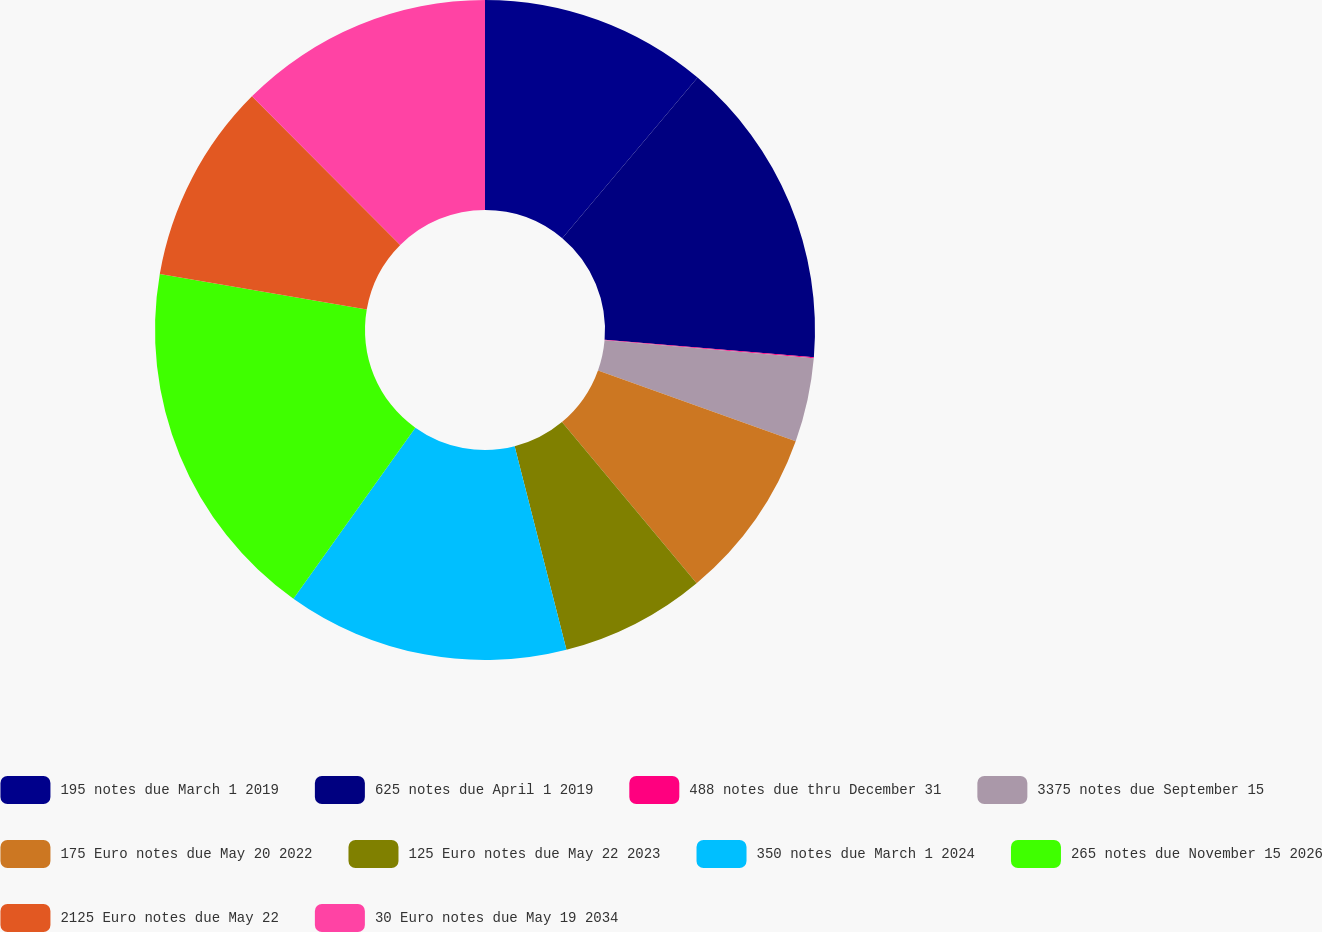<chart> <loc_0><loc_0><loc_500><loc_500><pie_chart><fcel>195 notes due March 1 2019<fcel>625 notes due April 1 2019<fcel>488 notes due thru December 31<fcel>3375 notes due September 15<fcel>175 Euro notes due May 20 2022<fcel>125 Euro notes due May 22 2023<fcel>350 notes due March 1 2024<fcel>265 notes due November 15 2026<fcel>2125 Euro notes due May 22<fcel>30 Euro notes due May 19 2034<nl><fcel>11.14%<fcel>15.17%<fcel>0.05%<fcel>4.11%<fcel>8.45%<fcel>7.11%<fcel>13.83%<fcel>17.86%<fcel>9.8%<fcel>12.48%<nl></chart> 